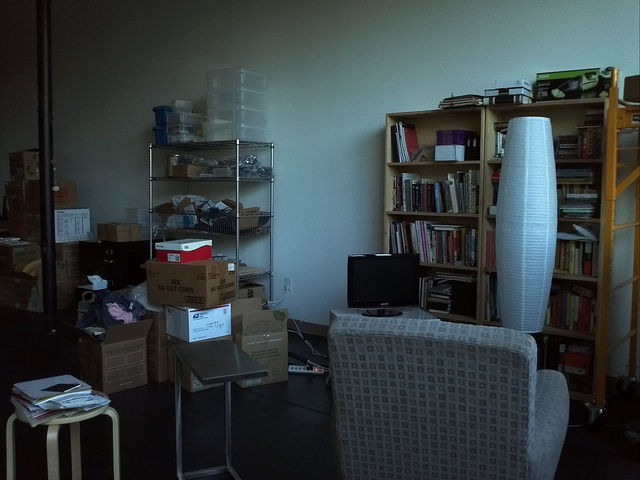Describe the objects in this image and their specific colors. I can see chair in black, blue, and darkblue tones, tv in black and gray tones, book in black, gray, and blue tones, book in black, maroon, and gray tones, and book in black tones in this image. 